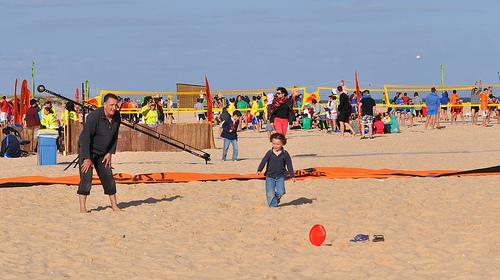Question: how many Frisbees are there?
Choices:
A. 1.
B. 2.
C. 3.
D. 4.
Answer with the letter. Answer: A Question: what is the Frisbee on?
Choices:
A. His head.
B. The hand.
C. The dog's nose.
D. The sand.
Answer with the letter. Answer: D Question: where was the picture taken?
Choices:
A. At the beach playground.
B. At a party.
C. At school.
D. At work.
Answer with the letter. Answer: A 